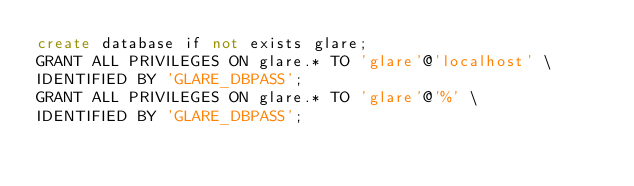<code> <loc_0><loc_0><loc_500><loc_500><_SQL_>create database if not exists glare;
GRANT ALL PRIVILEGES ON glare.* TO 'glare'@'localhost' \
IDENTIFIED BY 'GLARE_DBPASS';
GRANT ALL PRIVILEGES ON glare.* TO 'glare'@'%' \
IDENTIFIED BY 'GLARE_DBPASS';
</code> 